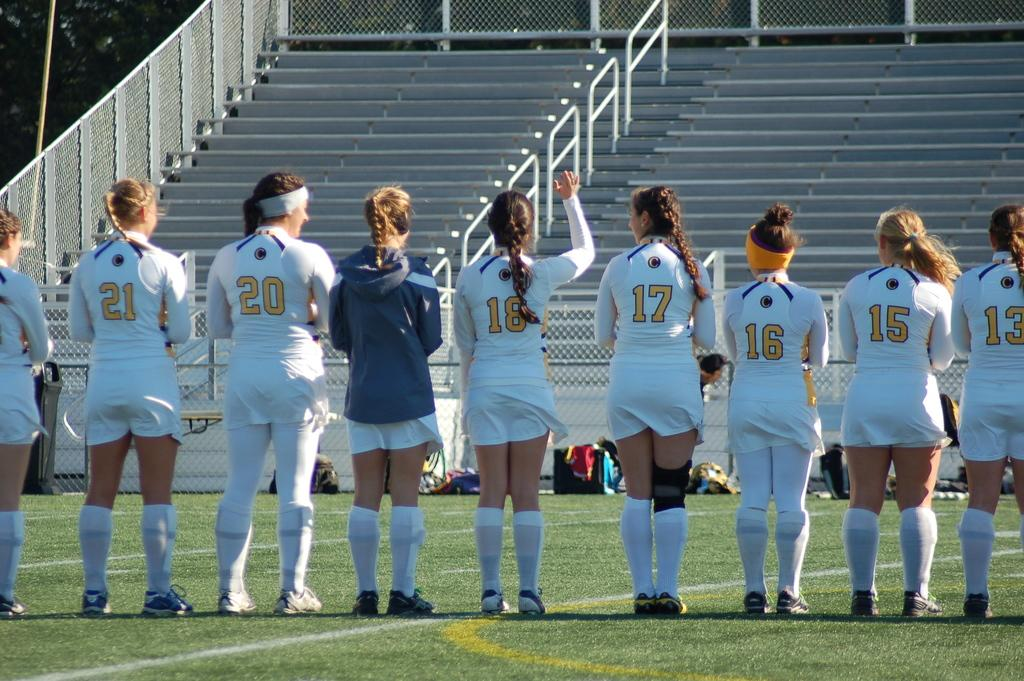<image>
Provide a brief description of the given image. Player number 17 on this team is wearing a black knee brace. 